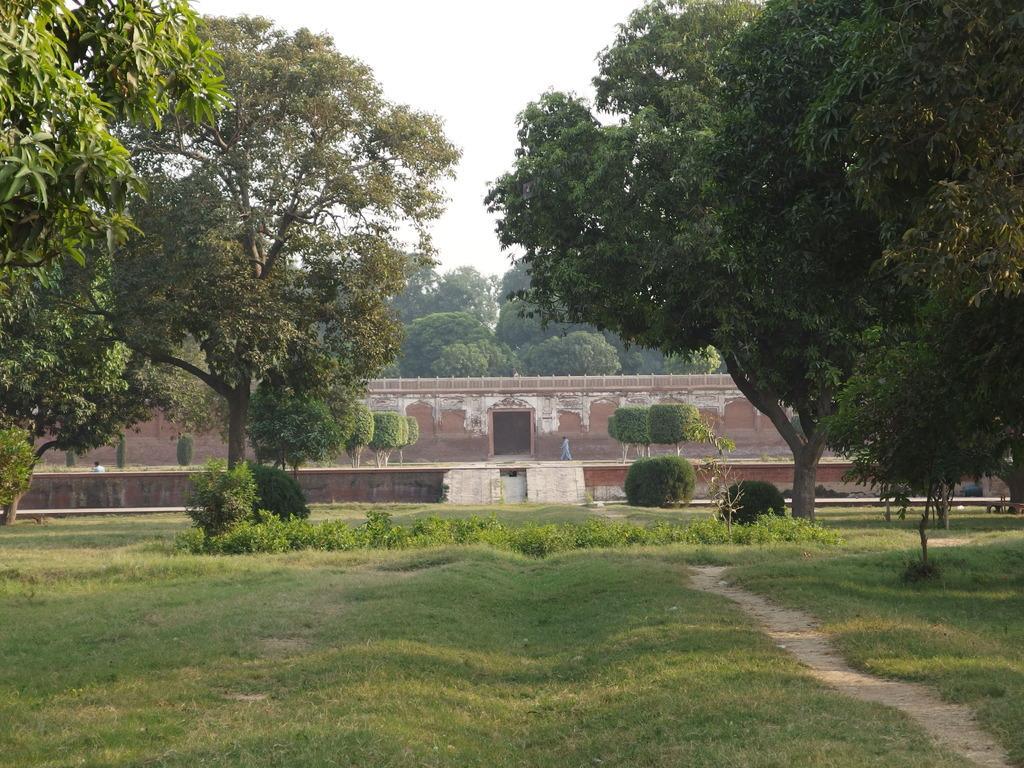In one or two sentences, can you explain what this image depicts? In this picture we can see so many trees, grass, one wall at back side. 